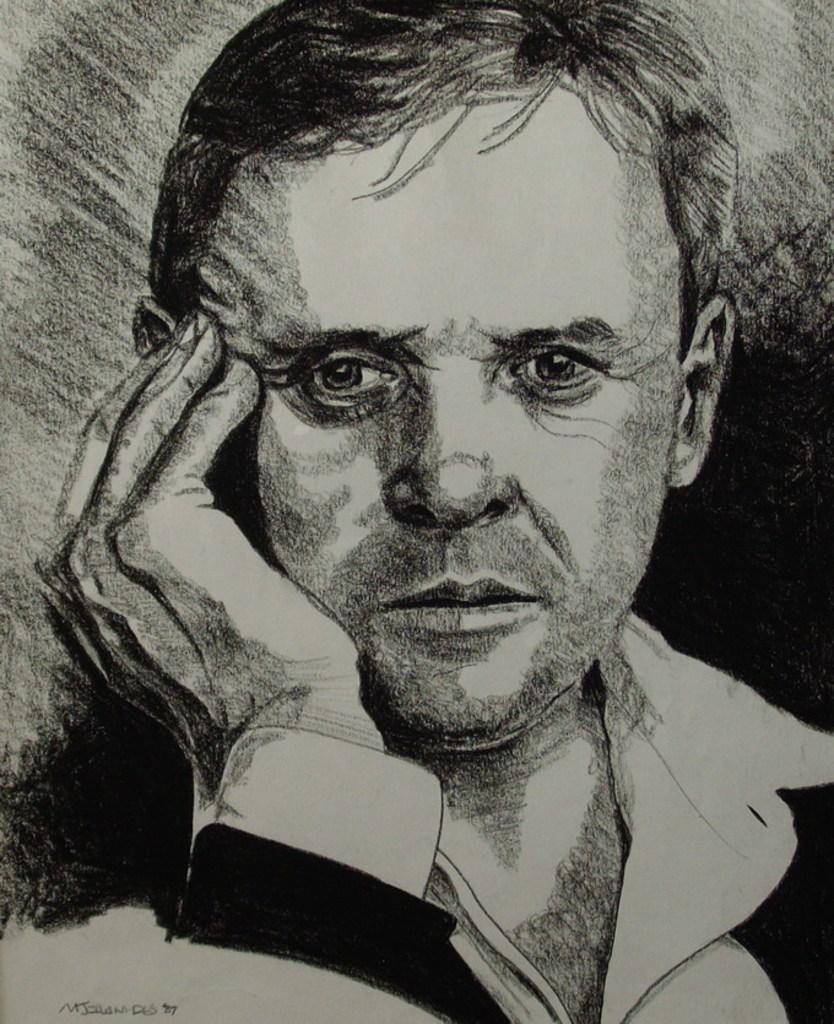What is the main subject of the image? There is an art piece in the image. What does the art piece depict? The art piece depicts a man. What is the man doing in the art piece? The man is keeping his hand on his face. What language is the governor speaking in the image? There is no governor or language spoken in the image; it features an art piece depicting a man with his hand on his face. 